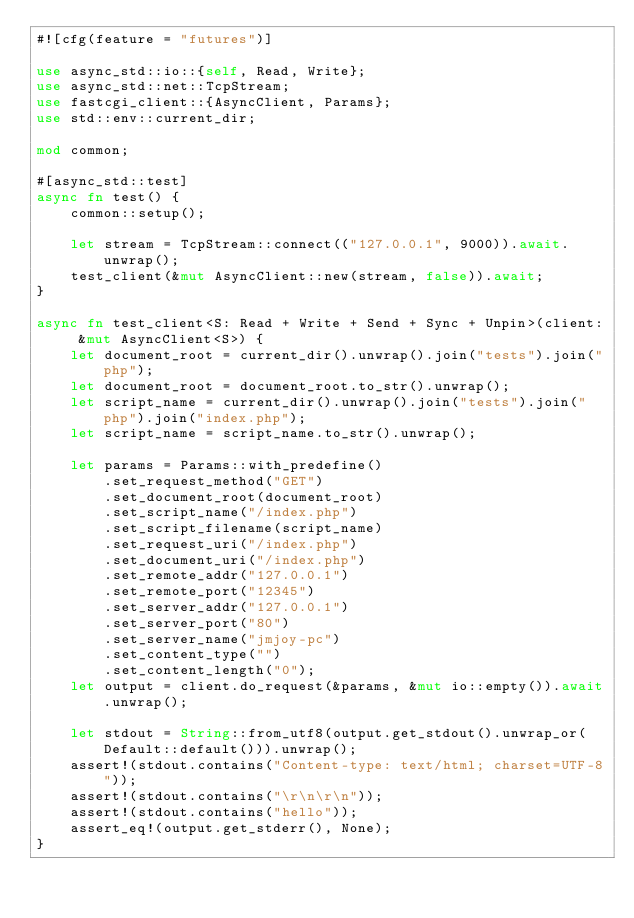Convert code to text. <code><loc_0><loc_0><loc_500><loc_500><_Rust_>#![cfg(feature = "futures")]

use async_std::io::{self, Read, Write};
use async_std::net::TcpStream;
use fastcgi_client::{AsyncClient, Params};
use std::env::current_dir;

mod common;

#[async_std::test]
async fn test() {
    common::setup();

    let stream = TcpStream::connect(("127.0.0.1", 9000)).await.unwrap();
    test_client(&mut AsyncClient::new(stream, false)).await;
}

async fn test_client<S: Read + Write + Send + Sync + Unpin>(client: &mut AsyncClient<S>) {
    let document_root = current_dir().unwrap().join("tests").join("php");
    let document_root = document_root.to_str().unwrap();
    let script_name = current_dir().unwrap().join("tests").join("php").join("index.php");
    let script_name = script_name.to_str().unwrap();

    let params = Params::with_predefine()
        .set_request_method("GET")
        .set_document_root(document_root)
        .set_script_name("/index.php")
        .set_script_filename(script_name)
        .set_request_uri("/index.php")
        .set_document_uri("/index.php")
        .set_remote_addr("127.0.0.1")
        .set_remote_port("12345")
        .set_server_addr("127.0.0.1")
        .set_server_port("80")
        .set_server_name("jmjoy-pc")
        .set_content_type("")
        .set_content_length("0");
    let output = client.do_request(&params, &mut io::empty()).await.unwrap();

    let stdout = String::from_utf8(output.get_stdout().unwrap_or(Default::default())).unwrap();
    assert!(stdout.contains("Content-type: text/html; charset=UTF-8"));
    assert!(stdout.contains("\r\n\r\n"));
    assert!(stdout.contains("hello"));
    assert_eq!(output.get_stderr(), None);
}
</code> 